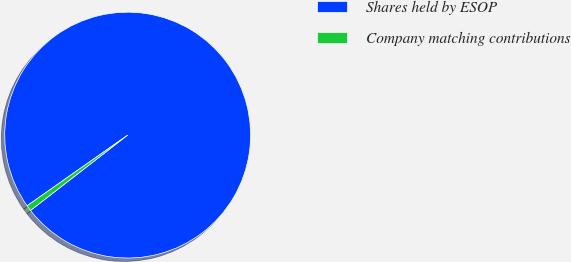<chart> <loc_0><loc_0><loc_500><loc_500><pie_chart><fcel>Shares held by ESOP<fcel>Company matching contributions<nl><fcel>99.25%<fcel>0.75%<nl></chart> 